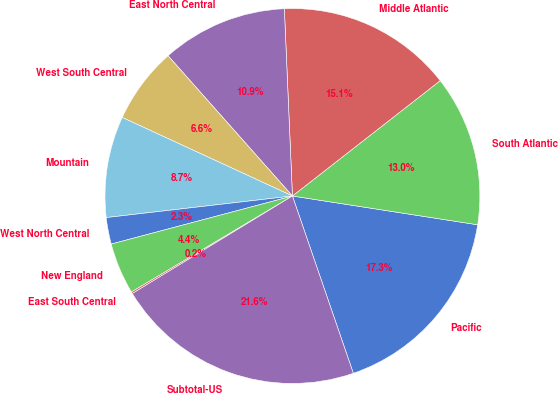Convert chart. <chart><loc_0><loc_0><loc_500><loc_500><pie_chart><fcel>Pacific<fcel>South Atlantic<fcel>Middle Atlantic<fcel>East North Central<fcel>West South Central<fcel>Mountain<fcel>West North Central<fcel>New England<fcel>East South Central<fcel>Subtotal-US<nl><fcel>17.28%<fcel>13.0%<fcel>15.14%<fcel>10.86%<fcel>6.57%<fcel>8.72%<fcel>2.29%<fcel>4.43%<fcel>0.15%<fcel>21.56%<nl></chart> 